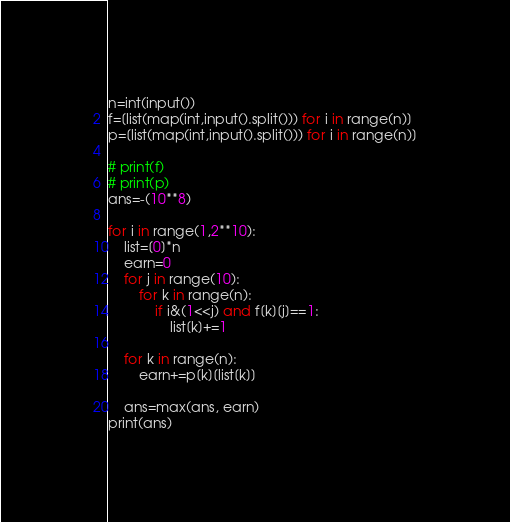Convert code to text. <code><loc_0><loc_0><loc_500><loc_500><_Python_>n=int(input())
f=[list(map(int,input().split())) for i in range(n)]
p=[list(map(int,input().split())) for i in range(n)]

# print(f)
# print(p)
ans=-(10**8)

for i in range(1,2**10):
    list=[0]*n
    earn=0
    for j in range(10):
        for k in range(n):
            if i&(1<<j) and f[k][j]==1:
                list[k]+=1
    
    for k in range(n):
        earn+=p[k][list[k]]
    
    ans=max(ans, earn)
print(ans)</code> 